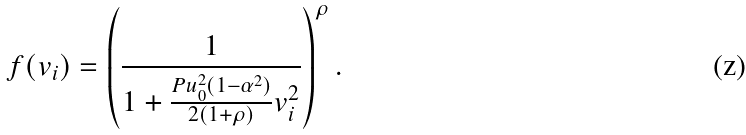<formula> <loc_0><loc_0><loc_500><loc_500>f ( v _ { i } ) = \left ( \frac { 1 } { 1 + \frac { P u _ { 0 } ^ { 2 } ( 1 - \alpha ^ { 2 } ) } { 2 ( 1 + \rho ) } v _ { i } ^ { 2 } } \right ) ^ { \rho } .</formula> 